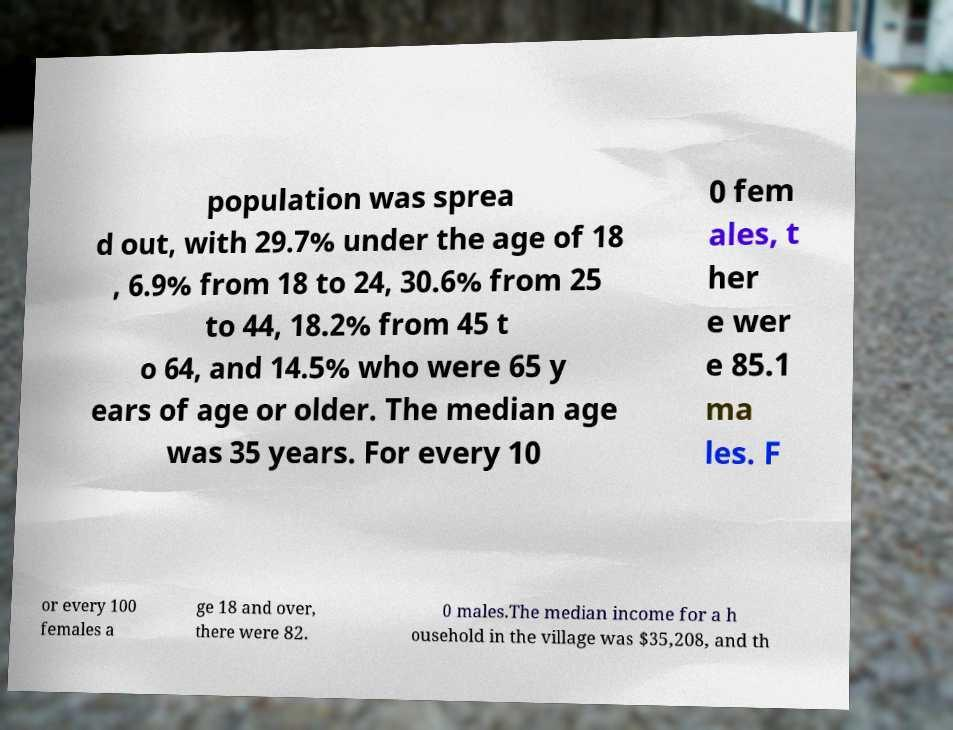I need the written content from this picture converted into text. Can you do that? population was sprea d out, with 29.7% under the age of 18 , 6.9% from 18 to 24, 30.6% from 25 to 44, 18.2% from 45 t o 64, and 14.5% who were 65 y ears of age or older. The median age was 35 years. For every 10 0 fem ales, t her e wer e 85.1 ma les. F or every 100 females a ge 18 and over, there were 82. 0 males.The median income for a h ousehold in the village was $35,208, and th 